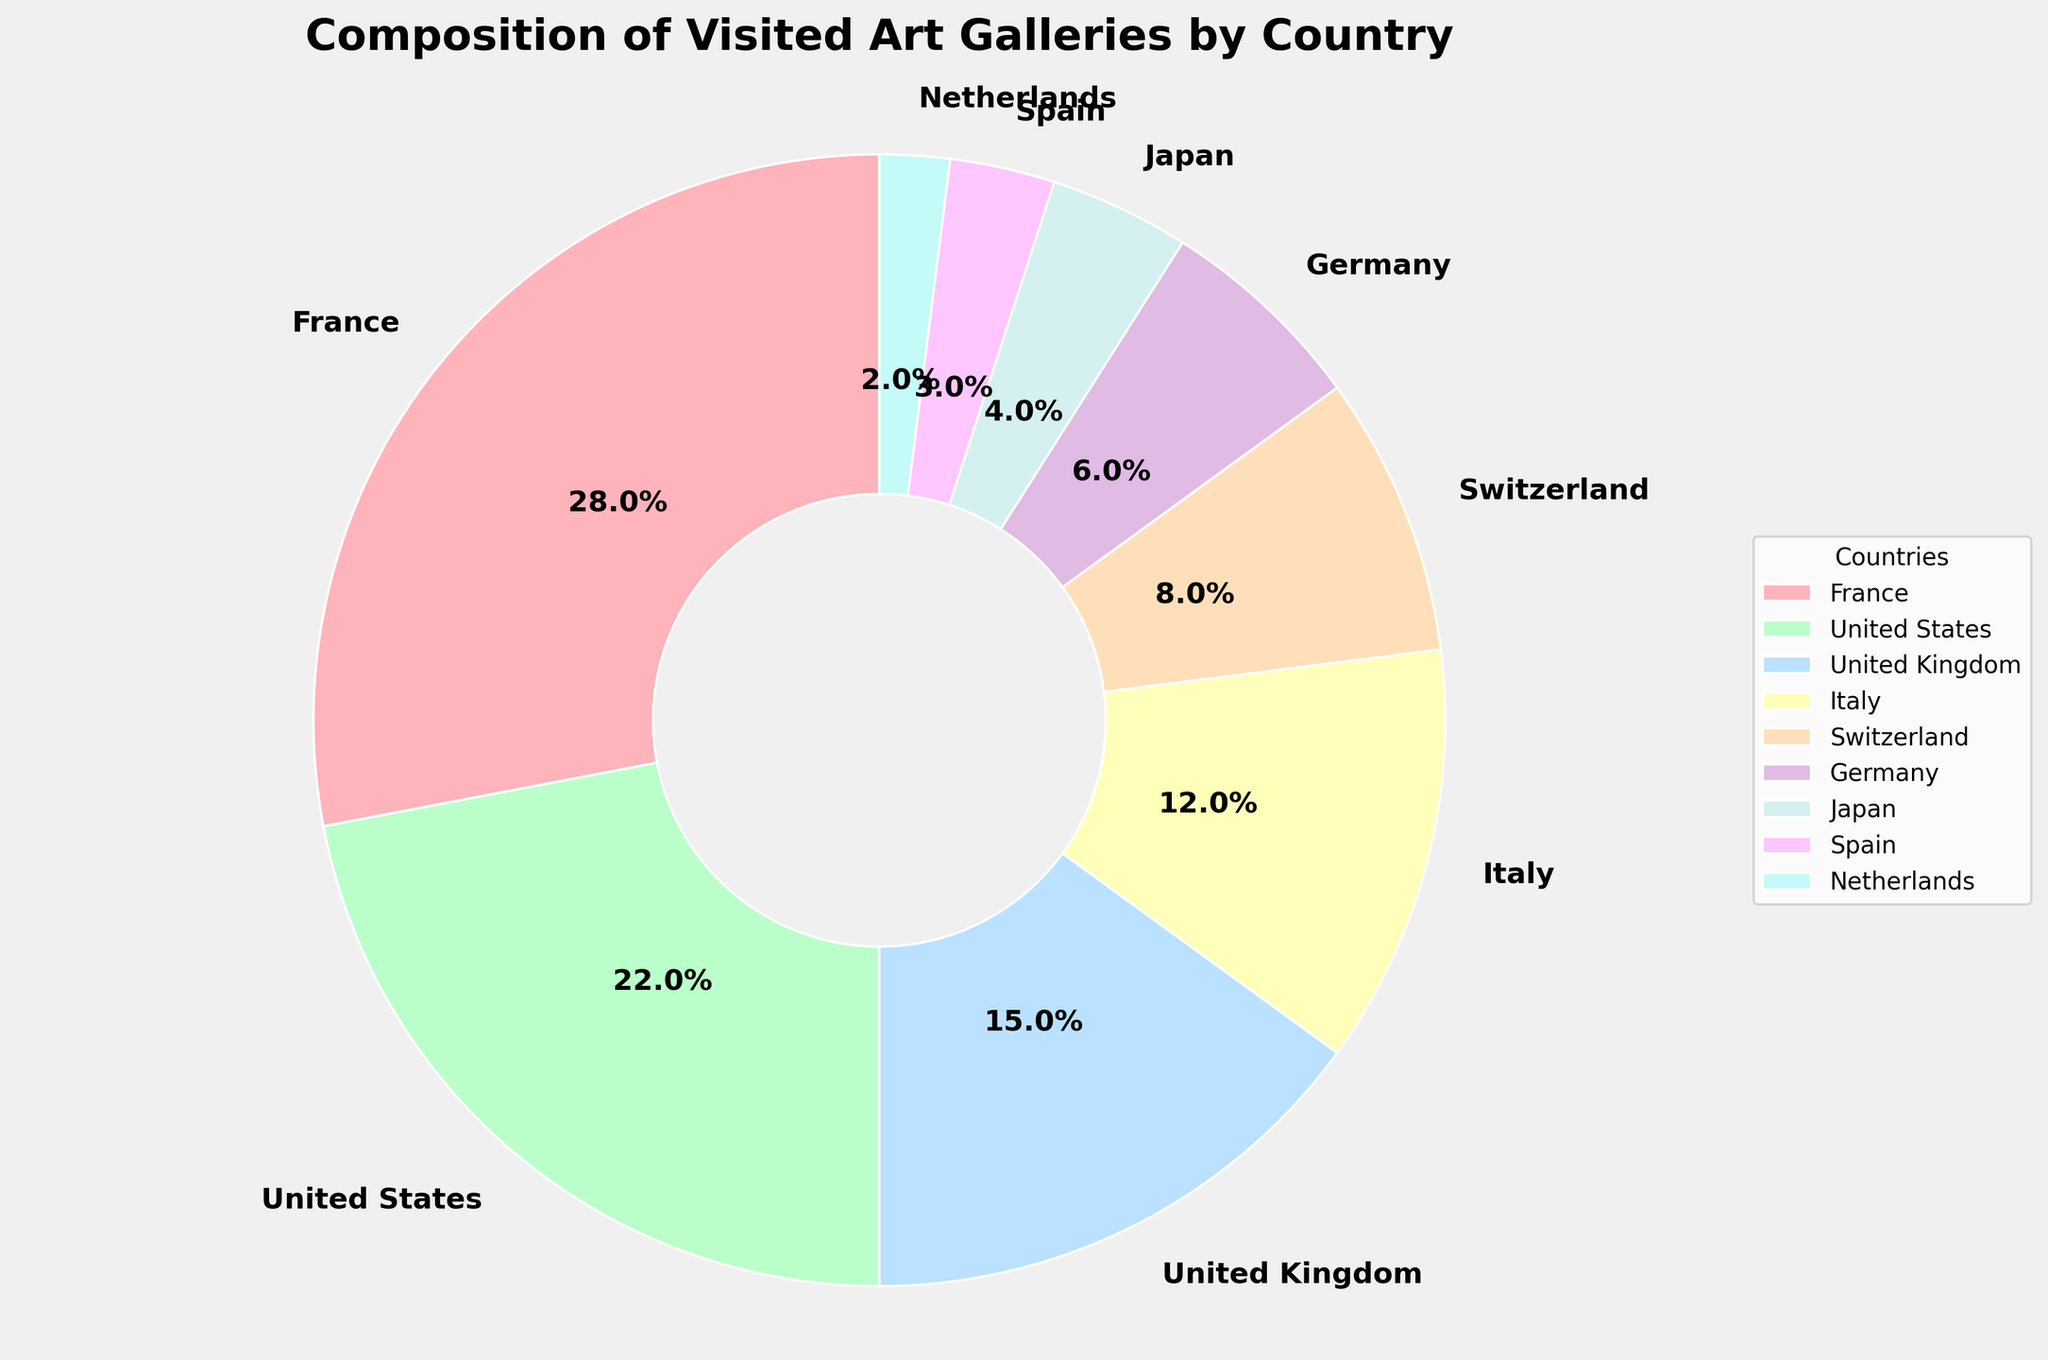Which country has the smallest percentage of visited art galleries? The smallest percentage is 2% which belongs to the Netherlands as shown in the pie chart.
Answer: Netherlands What's the difference in percentages between France and Germany? France has 28% and Germany has 6%. The difference is calculated as 28% - 6% = 22%.
Answer: 22% Which two countries combined account for more than half of the gallery visits? France (28%) and the United States (22%) combined make up 28% + 22% = 50%, which is exactly half. So, adding another country like the United Kingdom (15%) will make it more than half.
Answer: France and United States Which country has more visits, Japan or Switzerland? Switzerland has 8% while Japan has 4% according to the pie chart, so Switzerland has more visits.
Answer: Switzerland What is the total percentage of visits accounted for by Italy, Germany, and Japan together? Adding the percentages for Italy (12%), Germany (6%), and Japan (4%), we get 12% + 6% + 4% = 22%.
Answer: 22% Between the United Kingdom and Spain, which country is visited less and by how much? The United Kingdom accounts for 15%, while Spain has 3%. The difference is 15% - 3% = 12%. So, Spain is visited less by 12%.
Answer: Spain, by 12% How many countries account for at least 10% of the total gallery visits each? Checking the percentages, France (28%), United States (22%), United Kingdom (15%), and Italy (12%) are all above 10%. So, there are 4 countries.
Answer: 4 countries Which section of the pie chart is likely the largest visually, and why? The section representing France is the largest because it has the highest percentage of visited art galleries at 28%.
Answer: France Excluding France and the United States, what percentage of gallery visits is made up by the other countries combined? Excluding France (28%) and United States (22%), the remaining countries are the United Kingdom (15%), Italy (12%), Switzerland (8%), Germany (6%), Japan (4%), Spain (3%), and Netherlands (2%). Adding these, we get 15% + 12% + 8% + 6% + 4% + 3% + 2% = 50%.
Answer: 50% If you were to visually illustrate the dominance of European countries in the pie chart, which countries and colors would you highlight? Highlight France (red), United Kingdom (blue), Italy (yellow), Switzerland (orange), Germany (pink), Spain (light orange), and Netherlands (cyan) as these European countries together show significant representation.
Answer: France (red), United Kingdom (blue), Italy (yellow), Switzerland (orange), Germany (pink), Spain (light orange), Netherlands (cyan) 